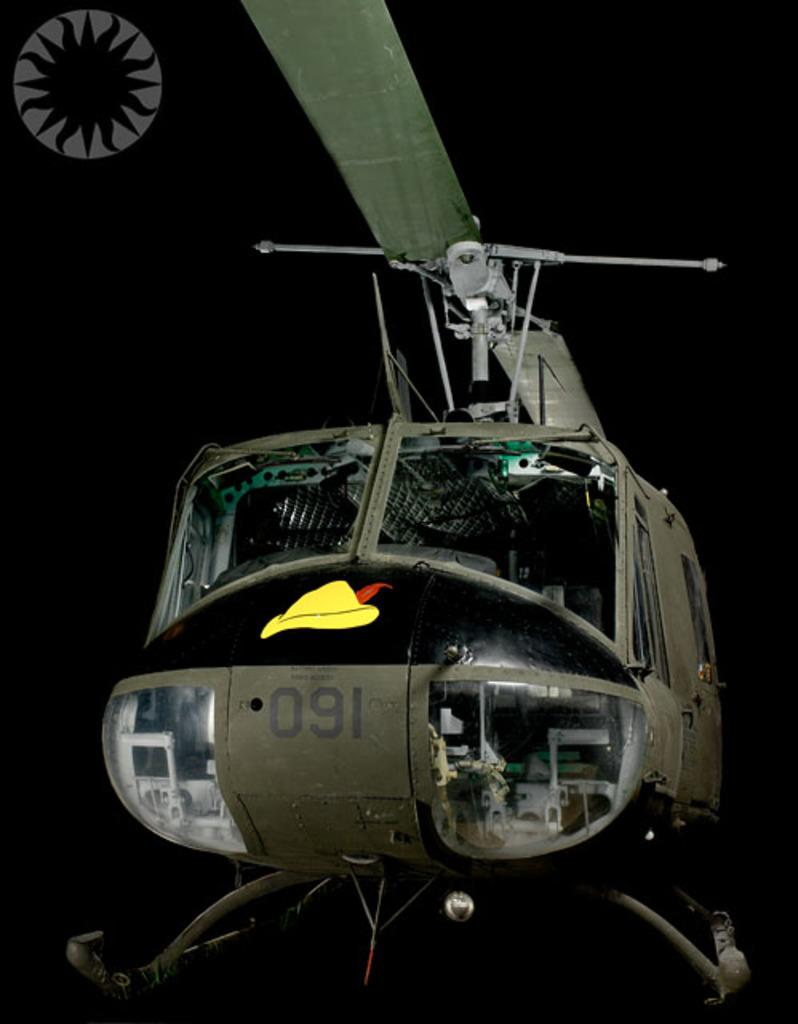<image>
Present a compact description of the photo's key features. A disaplay of a grenish brown helicopter with the numbers 091 written on the front. 